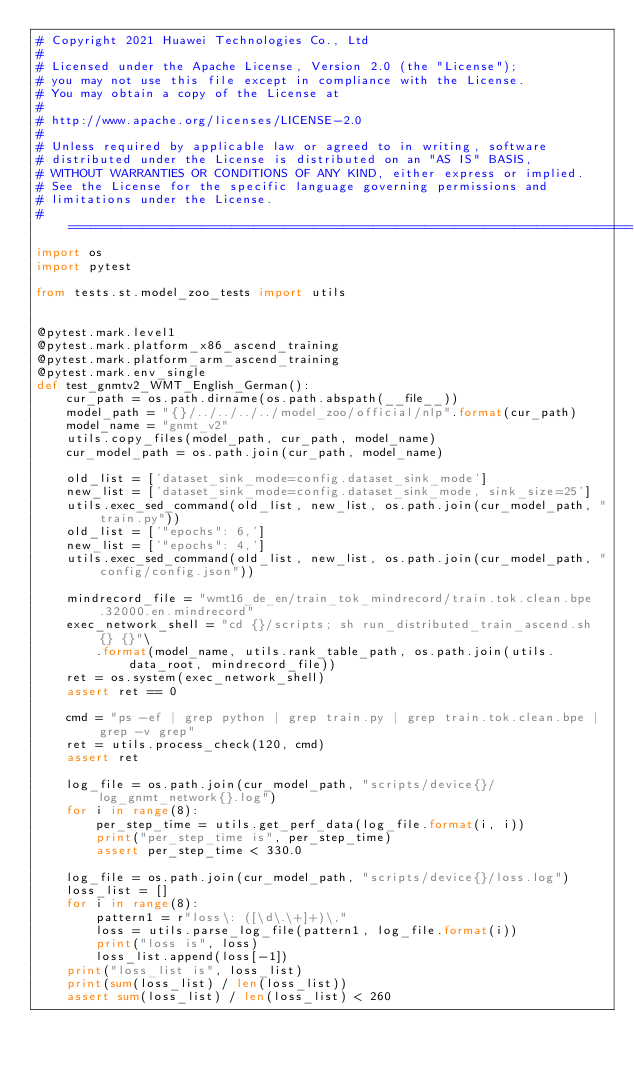Convert code to text. <code><loc_0><loc_0><loc_500><loc_500><_Python_># Copyright 2021 Huawei Technologies Co., Ltd
#
# Licensed under the Apache License, Version 2.0 (the "License");
# you may not use this file except in compliance with the License.
# You may obtain a copy of the License at
#
# http://www.apache.org/licenses/LICENSE-2.0
#
# Unless required by applicable law or agreed to in writing, software
# distributed under the License is distributed on an "AS IS" BASIS,
# WITHOUT WARRANTIES OR CONDITIONS OF ANY KIND, either express or implied.
# See the License for the specific language governing permissions and
# limitations under the License.
# ============================================================================
import os
import pytest

from tests.st.model_zoo_tests import utils


@pytest.mark.level1
@pytest.mark.platform_x86_ascend_training
@pytest.mark.platform_arm_ascend_training
@pytest.mark.env_single
def test_gnmtv2_WMT_English_German():
    cur_path = os.path.dirname(os.path.abspath(__file__))
    model_path = "{}/../../../../model_zoo/official/nlp".format(cur_path)
    model_name = "gnmt_v2"
    utils.copy_files(model_path, cur_path, model_name)
    cur_model_path = os.path.join(cur_path, model_name)

    old_list = ['dataset_sink_mode=config.dataset_sink_mode']
    new_list = ['dataset_sink_mode=config.dataset_sink_mode, sink_size=25']
    utils.exec_sed_command(old_list, new_list, os.path.join(cur_model_path, "train.py"))
    old_list = ['"epochs": 6,']
    new_list = ['"epochs": 4,']
    utils.exec_sed_command(old_list, new_list, os.path.join(cur_model_path, "config/config.json"))

    mindrecord_file = "wmt16_de_en/train_tok_mindrecord/train.tok.clean.bpe.32000.en.mindrecord"
    exec_network_shell = "cd {}/scripts; sh run_distributed_train_ascend.sh {} {}"\
        .format(model_name, utils.rank_table_path, os.path.join(utils.data_root, mindrecord_file))
    ret = os.system(exec_network_shell)
    assert ret == 0

    cmd = "ps -ef | grep python | grep train.py | grep train.tok.clean.bpe | grep -v grep"
    ret = utils.process_check(120, cmd)
    assert ret

    log_file = os.path.join(cur_model_path, "scripts/device{}/log_gnmt_network{}.log")
    for i in range(8):
        per_step_time = utils.get_perf_data(log_file.format(i, i))
        print("per_step_time is", per_step_time)
        assert per_step_time < 330.0

    log_file = os.path.join(cur_model_path, "scripts/device{}/loss.log")
    loss_list = []
    for i in range(8):
        pattern1 = r"loss\: ([\d\.\+]+)\,"
        loss = utils.parse_log_file(pattern1, log_file.format(i))
        print("loss is", loss)
        loss_list.append(loss[-1])
    print("loss_list is", loss_list)
    print(sum(loss_list) / len(loss_list))
    assert sum(loss_list) / len(loss_list) < 260
</code> 